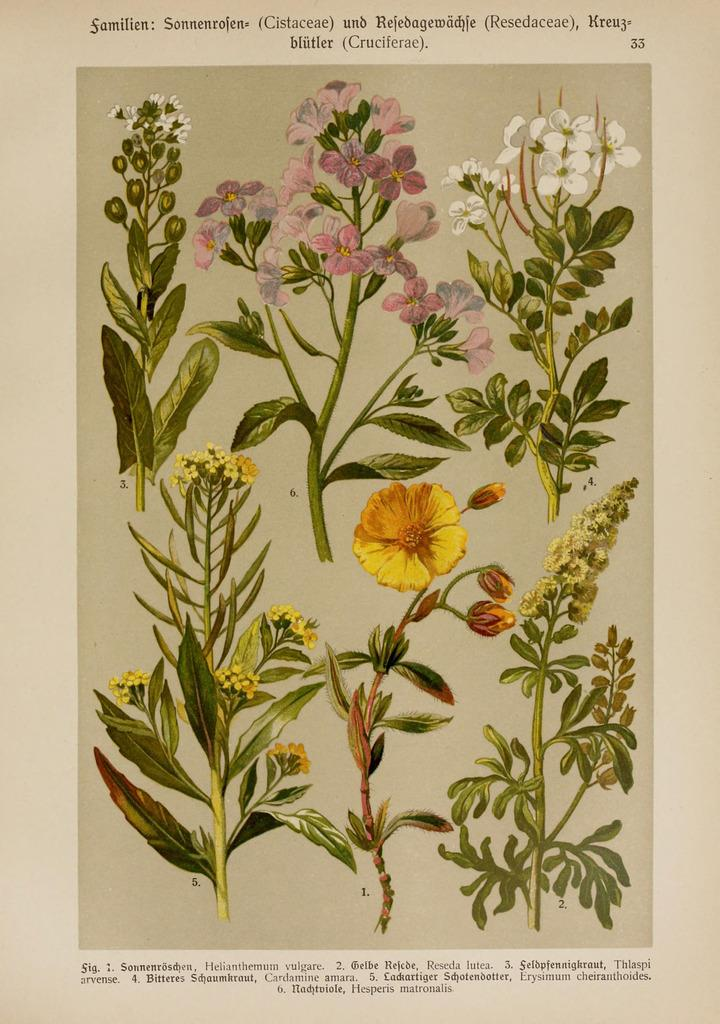What is the main subject of the poster in the image? The poster contains images of plants. Where are the names of the plants located on the poster? The names of the plants are at the bottom of the poster. Who is the author of the poster? The author's name is at the top of the poster. What type of pen is the goat using to write the names of the plants on the poster? There is no goat or pen present in the image. The poster contains images of plants, and the names of the plants are already written at the bottom of the poster. 